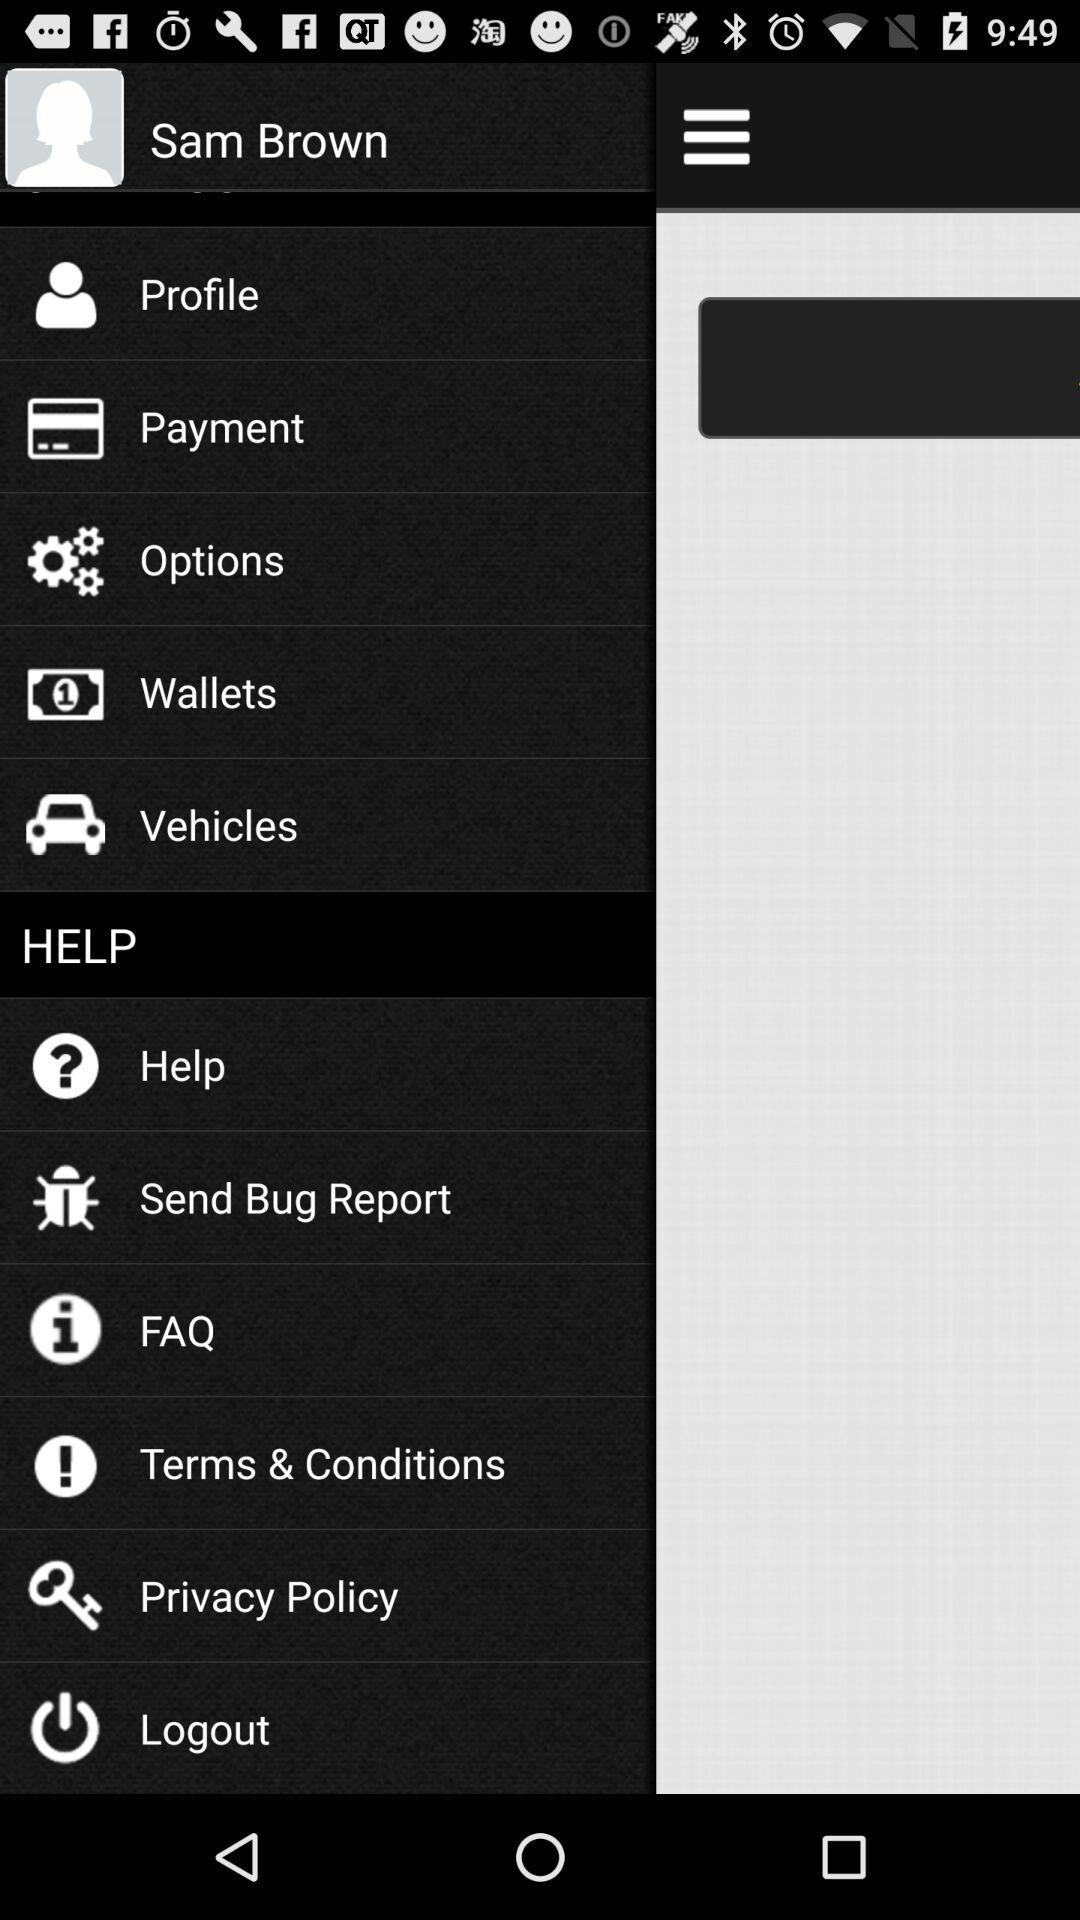What's the user profile name? The user profile name is Sam Brown. 